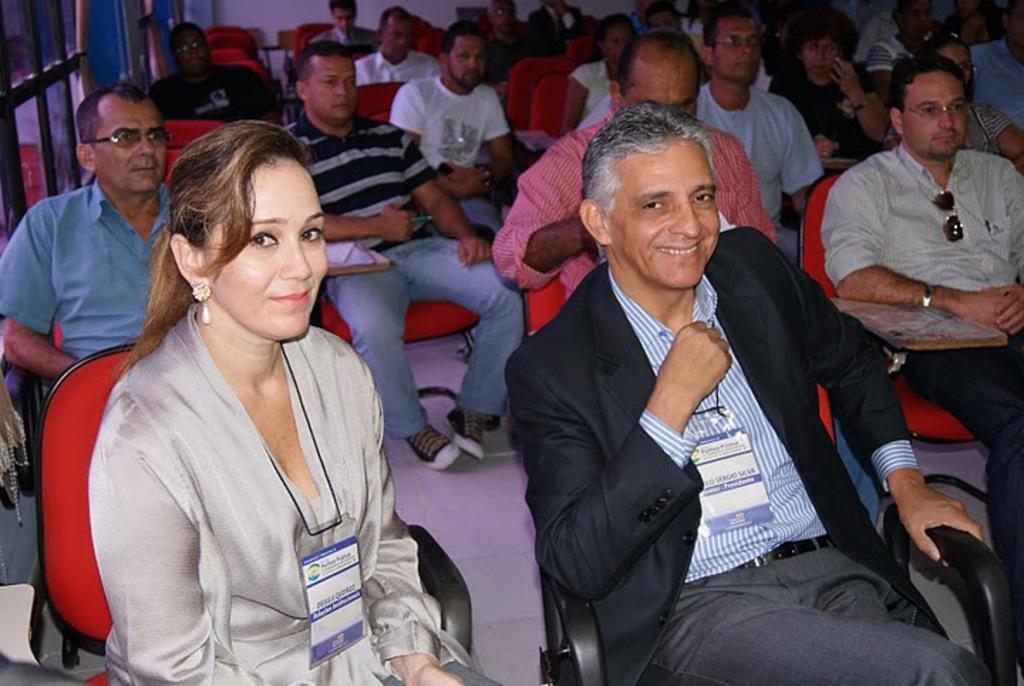Can you describe this image briefly? In this image, we can see there are persons in different color dresses, sitting on red color chairs which are arranged on the white color floor. Some of them are smiling. In the background, there is a white wall and there are glass windows. 